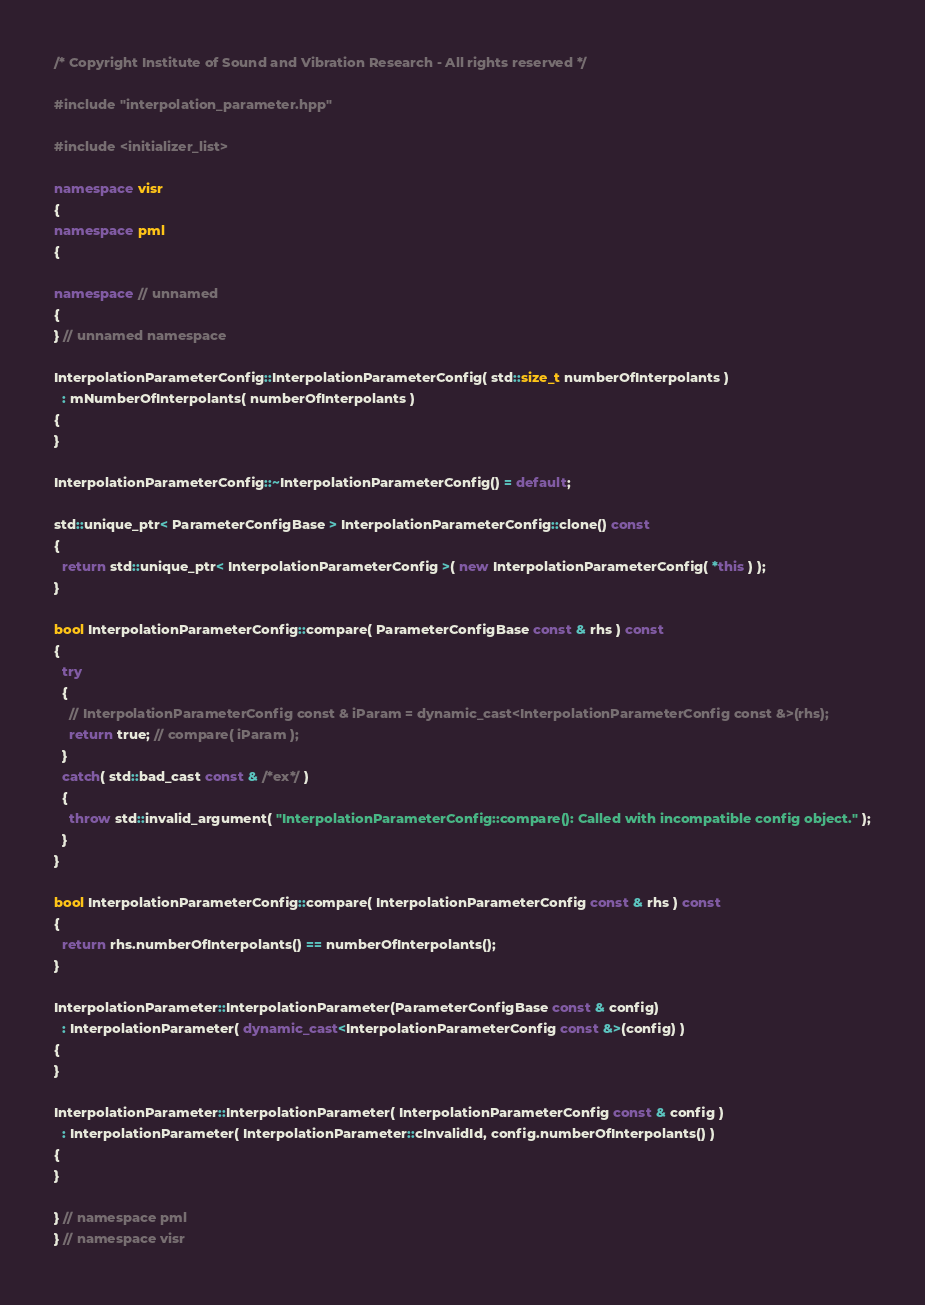Convert code to text. <code><loc_0><loc_0><loc_500><loc_500><_C++_>/* Copyright Institute of Sound and Vibration Research - All rights reserved */

#include "interpolation_parameter.hpp"

#include <initializer_list>

namespace visr
{
namespace pml
{

namespace // unnamed
{
} // unnamed namespace

InterpolationParameterConfig::InterpolationParameterConfig( std::size_t numberOfInterpolants )
  : mNumberOfInterpolants( numberOfInterpolants )
{
}

InterpolationParameterConfig::~InterpolationParameterConfig() = default;

std::unique_ptr< ParameterConfigBase > InterpolationParameterConfig::clone() const
{
  return std::unique_ptr< InterpolationParameterConfig >( new InterpolationParameterConfig( *this ) );
}

bool InterpolationParameterConfig::compare( ParameterConfigBase const & rhs ) const
{
  try
  {
    // InterpolationParameterConfig const & iParam = dynamic_cast<InterpolationParameterConfig const &>(rhs);
    return true; // compare( iParam );
  }
  catch( std::bad_cast const & /*ex*/ )
  {
    throw std::invalid_argument( "InterpolationParameterConfig::compare(): Called with incompatible config object." );
  }
}

bool InterpolationParameterConfig::compare( InterpolationParameterConfig const & rhs ) const
{
  return rhs.numberOfInterpolants() == numberOfInterpolants();
}

InterpolationParameter::InterpolationParameter(ParameterConfigBase const & config)
  : InterpolationParameter( dynamic_cast<InterpolationParameterConfig const &>(config) )
{
}

InterpolationParameter::InterpolationParameter( InterpolationParameterConfig const & config )
  : InterpolationParameter( InterpolationParameter::cInvalidId, config.numberOfInterpolants() )
{
}

} // namespace pml
} // namespace visr
</code> 